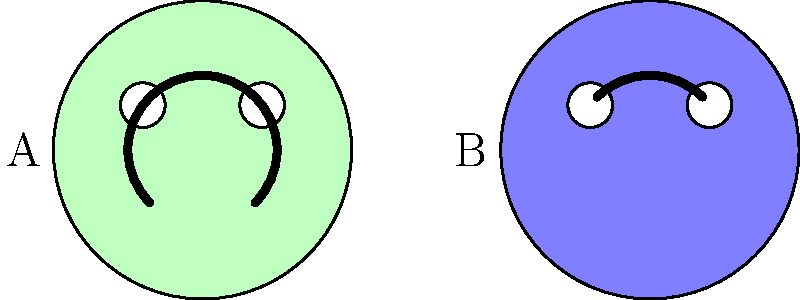Which painted face on the decorative pillow represents a happy emotion that would be more suitable for a child's room? To determine which painted face represents a happy emotion more suitable for a child's room, we need to analyze the facial expressions of both pillows:

1. Pillow A (left):
   - The mouth is curved upwards in a wide arc.
   - The eyes are open and round.
   - The overall expression appears cheerful and welcoming.

2. Pillow B (right):
   - The mouth is a straight line.
   - The eyes are open and round.
   - The overall expression appears neutral or slightly serious.

3. Comparing the two:
   - Pillow A's upward-curved mouth is a universal sign of happiness or joy.
   - Pillow B's straight-line mouth doesn't convey any particular emotion.

4. Considering the context of a child's room:
   - Children generally respond positively to happy, cheerful images.
   - A smiling face can create a more comforting and pleasant atmosphere.

5. Conclusion:
   Pillow A, with its smiling expression, represents a happy emotion and would be more suitable for decorating a child's room.
Answer: A 